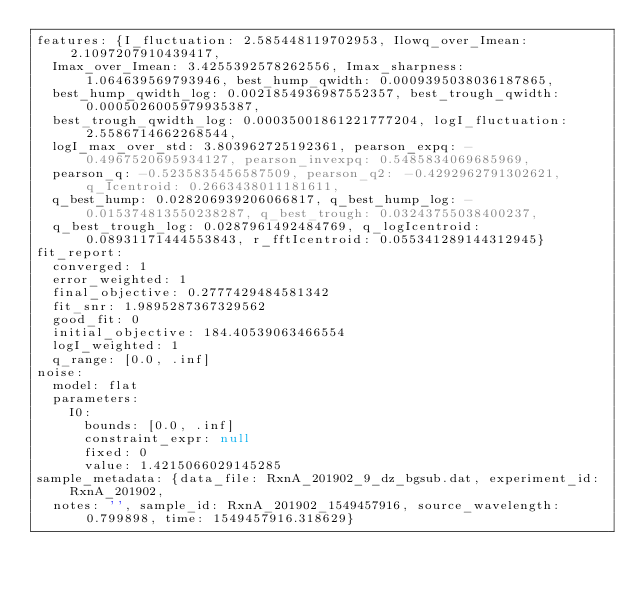<code> <loc_0><loc_0><loc_500><loc_500><_YAML_>features: {I_fluctuation: 2.585448119702953, Ilowq_over_Imean: 2.1097207910439417,
  Imax_over_Imean: 3.4255392578262556, Imax_sharpness: 1.064639569793946, best_hump_qwidth: 0.0009395038036187865,
  best_hump_qwidth_log: 0.0021854936987552357, best_trough_qwidth: 0.0005026005979935387,
  best_trough_qwidth_log: 0.00035001861221777204, logI_fluctuation: 2.5586714662268544,
  logI_max_over_std: 3.803962725192361, pearson_expq: -0.4967520695934127, pearson_invexpq: 0.5485834069685969,
  pearson_q: -0.5235835456587509, pearson_q2: -0.4292962791302621, q_Icentroid: 0.2663438011181611,
  q_best_hump: 0.028206939206066817, q_best_hump_log: -0.015374813550238287, q_best_trough: 0.03243755038400237,
  q_best_trough_log: 0.0287961492484769, q_logIcentroid: 0.08931171444553843, r_fftIcentroid: 0.055341289144312945}
fit_report:
  converged: 1
  error_weighted: 1
  final_objective: 0.2777429484581342
  fit_snr: 1.9895287367329562
  good_fit: 0
  initial_objective: 184.40539063466554
  logI_weighted: 1
  q_range: [0.0, .inf]
noise:
  model: flat
  parameters:
    I0:
      bounds: [0.0, .inf]
      constraint_expr: null
      fixed: 0
      value: 1.4215066029145285
sample_metadata: {data_file: RxnA_201902_9_dz_bgsub.dat, experiment_id: RxnA_201902,
  notes: '', sample_id: RxnA_201902_1549457916, source_wavelength: 0.799898, time: 1549457916.318629}
</code> 